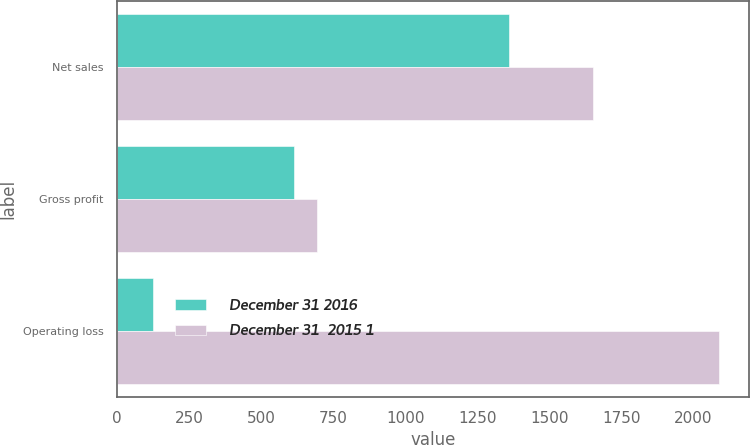<chart> <loc_0><loc_0><loc_500><loc_500><stacked_bar_chart><ecel><fcel>Net sales<fcel>Gross profit<fcel>Operating loss<nl><fcel>December 31 2016<fcel>1360.6<fcel>614.7<fcel>124.3<nl><fcel>December 31  2015 1<fcel>1652.2<fcel>693.4<fcel>2087.4<nl></chart> 